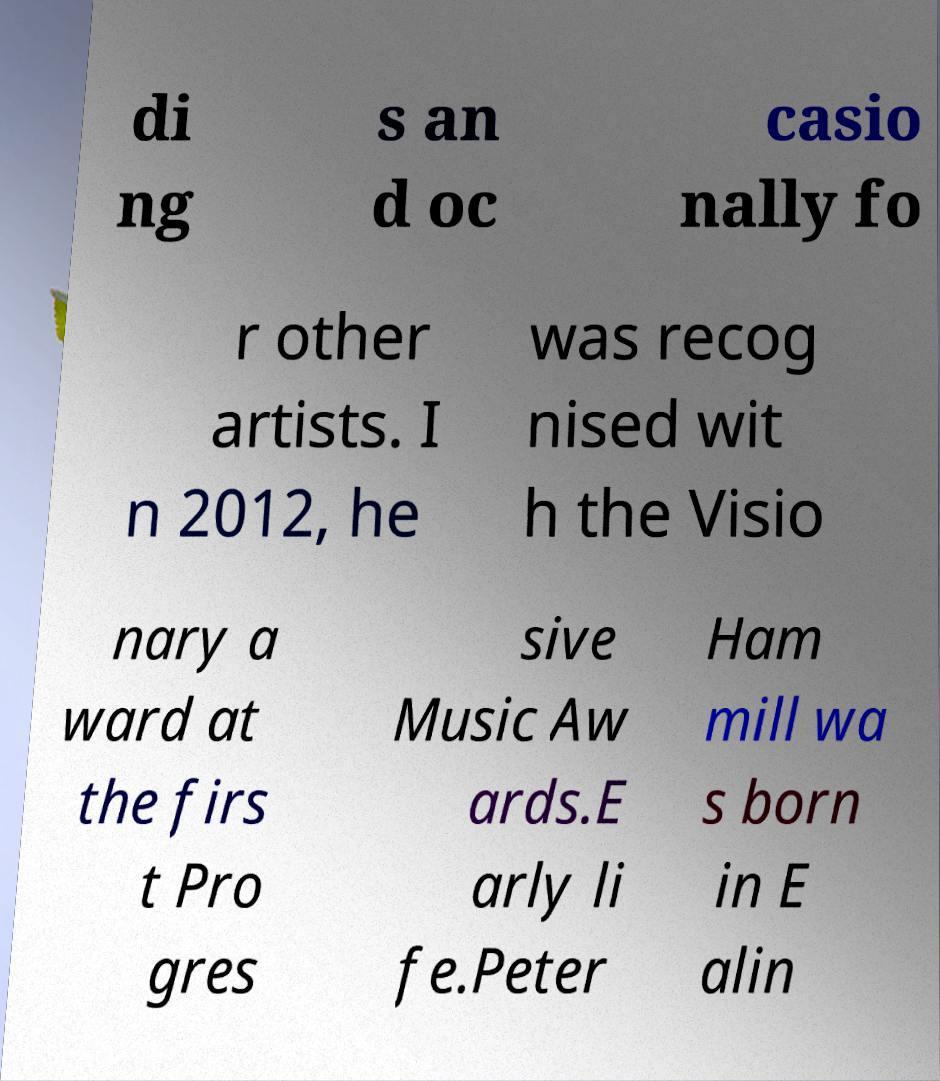For documentation purposes, I need the text within this image transcribed. Could you provide that? di ng s an d oc casio nally fo r other artists. I n 2012, he was recog nised wit h the Visio nary a ward at the firs t Pro gres sive Music Aw ards.E arly li fe.Peter Ham mill wa s born in E alin 